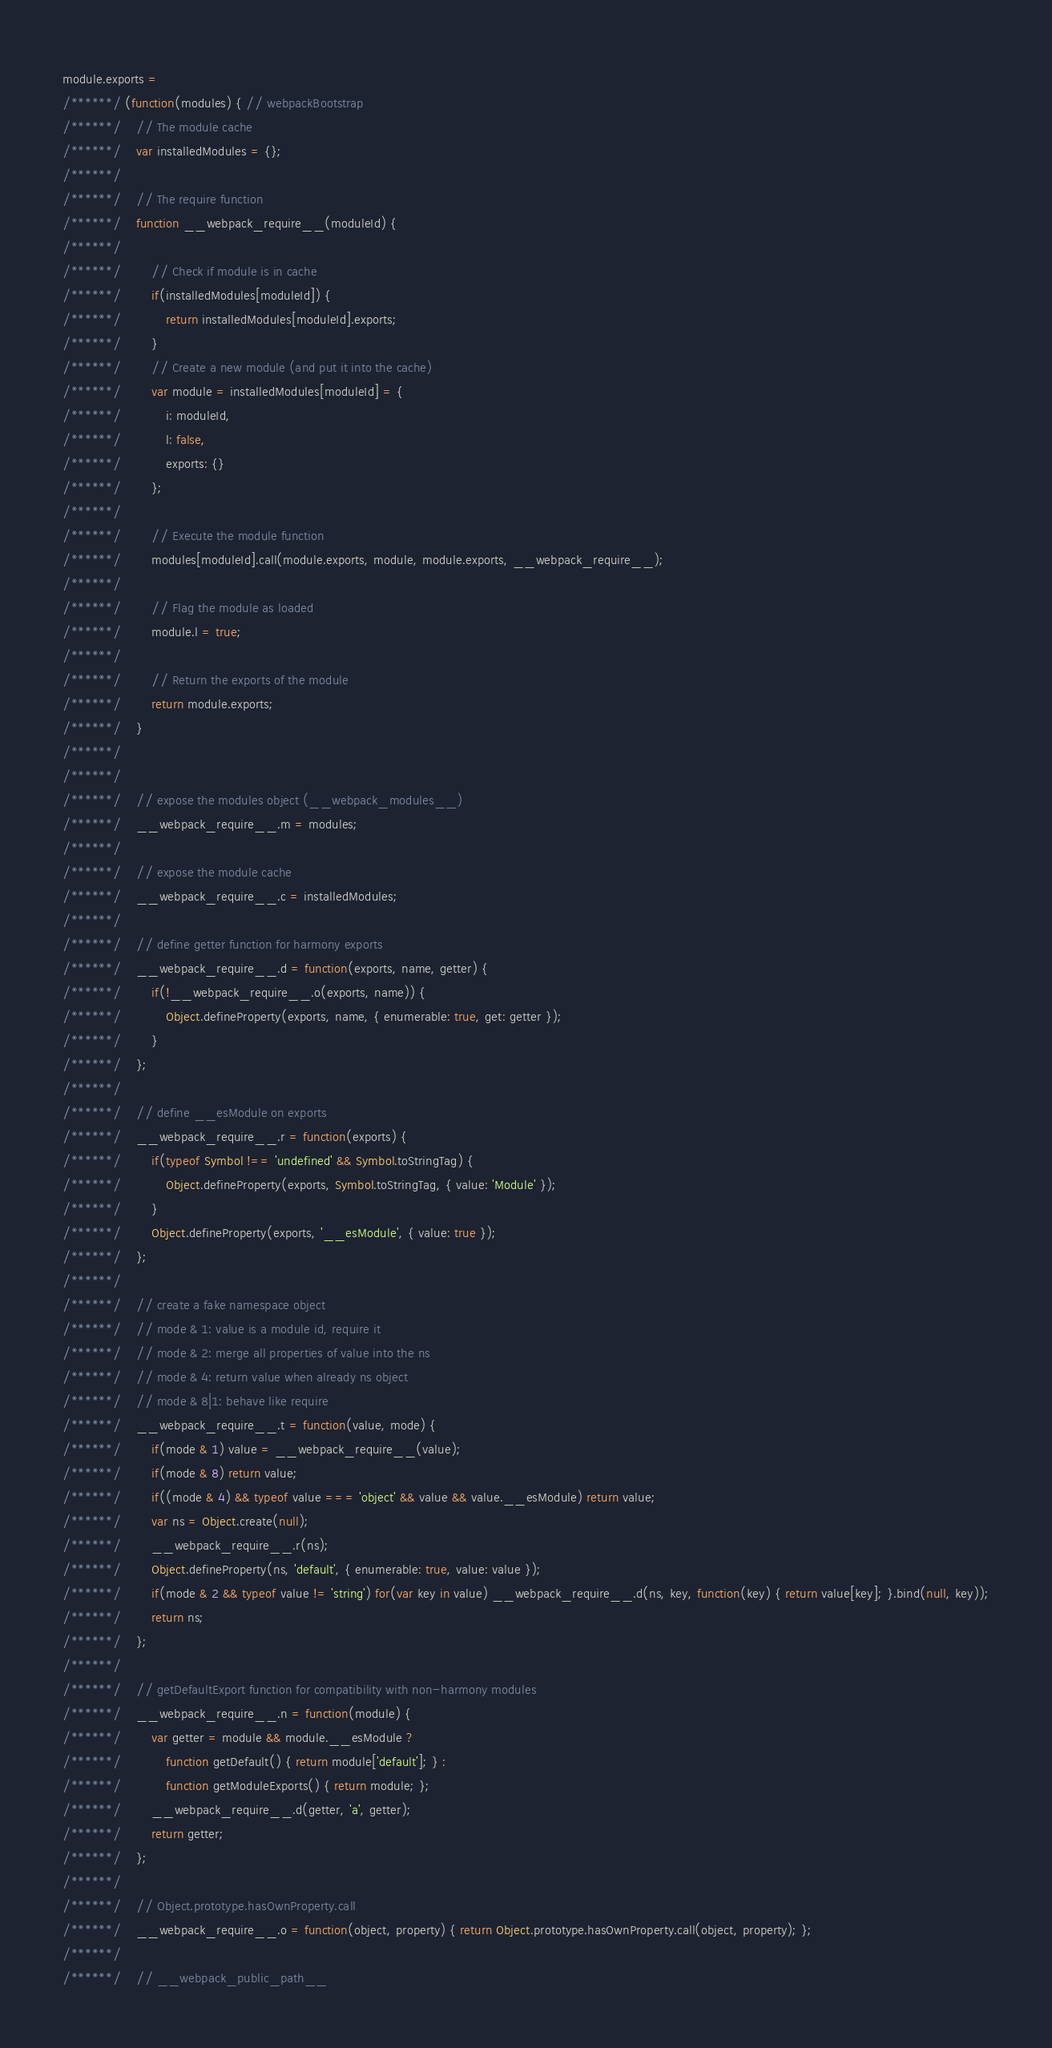<code> <loc_0><loc_0><loc_500><loc_500><_JavaScript_>module.exports =
/******/ (function(modules) { // webpackBootstrap
/******/ 	// The module cache
/******/ 	var installedModules = {};
/******/
/******/ 	// The require function
/******/ 	function __webpack_require__(moduleId) {
/******/
/******/ 		// Check if module is in cache
/******/ 		if(installedModules[moduleId]) {
/******/ 			return installedModules[moduleId].exports;
/******/ 		}
/******/ 		// Create a new module (and put it into the cache)
/******/ 		var module = installedModules[moduleId] = {
/******/ 			i: moduleId,
/******/ 			l: false,
/******/ 			exports: {}
/******/ 		};
/******/
/******/ 		// Execute the module function
/******/ 		modules[moduleId].call(module.exports, module, module.exports, __webpack_require__);
/******/
/******/ 		// Flag the module as loaded
/******/ 		module.l = true;
/******/
/******/ 		// Return the exports of the module
/******/ 		return module.exports;
/******/ 	}
/******/
/******/
/******/ 	// expose the modules object (__webpack_modules__)
/******/ 	__webpack_require__.m = modules;
/******/
/******/ 	// expose the module cache
/******/ 	__webpack_require__.c = installedModules;
/******/
/******/ 	// define getter function for harmony exports
/******/ 	__webpack_require__.d = function(exports, name, getter) {
/******/ 		if(!__webpack_require__.o(exports, name)) {
/******/ 			Object.defineProperty(exports, name, { enumerable: true, get: getter });
/******/ 		}
/******/ 	};
/******/
/******/ 	// define __esModule on exports
/******/ 	__webpack_require__.r = function(exports) {
/******/ 		if(typeof Symbol !== 'undefined' && Symbol.toStringTag) {
/******/ 			Object.defineProperty(exports, Symbol.toStringTag, { value: 'Module' });
/******/ 		}
/******/ 		Object.defineProperty(exports, '__esModule', { value: true });
/******/ 	};
/******/
/******/ 	// create a fake namespace object
/******/ 	// mode & 1: value is a module id, require it
/******/ 	// mode & 2: merge all properties of value into the ns
/******/ 	// mode & 4: return value when already ns object
/******/ 	// mode & 8|1: behave like require
/******/ 	__webpack_require__.t = function(value, mode) {
/******/ 		if(mode & 1) value = __webpack_require__(value);
/******/ 		if(mode & 8) return value;
/******/ 		if((mode & 4) && typeof value === 'object' && value && value.__esModule) return value;
/******/ 		var ns = Object.create(null);
/******/ 		__webpack_require__.r(ns);
/******/ 		Object.defineProperty(ns, 'default', { enumerable: true, value: value });
/******/ 		if(mode & 2 && typeof value != 'string') for(var key in value) __webpack_require__.d(ns, key, function(key) { return value[key]; }.bind(null, key));
/******/ 		return ns;
/******/ 	};
/******/
/******/ 	// getDefaultExport function for compatibility with non-harmony modules
/******/ 	__webpack_require__.n = function(module) {
/******/ 		var getter = module && module.__esModule ?
/******/ 			function getDefault() { return module['default']; } :
/******/ 			function getModuleExports() { return module; };
/******/ 		__webpack_require__.d(getter, 'a', getter);
/******/ 		return getter;
/******/ 	};
/******/
/******/ 	// Object.prototype.hasOwnProperty.call
/******/ 	__webpack_require__.o = function(object, property) { return Object.prototype.hasOwnProperty.call(object, property); };
/******/
/******/ 	// __webpack_public_path__</code> 